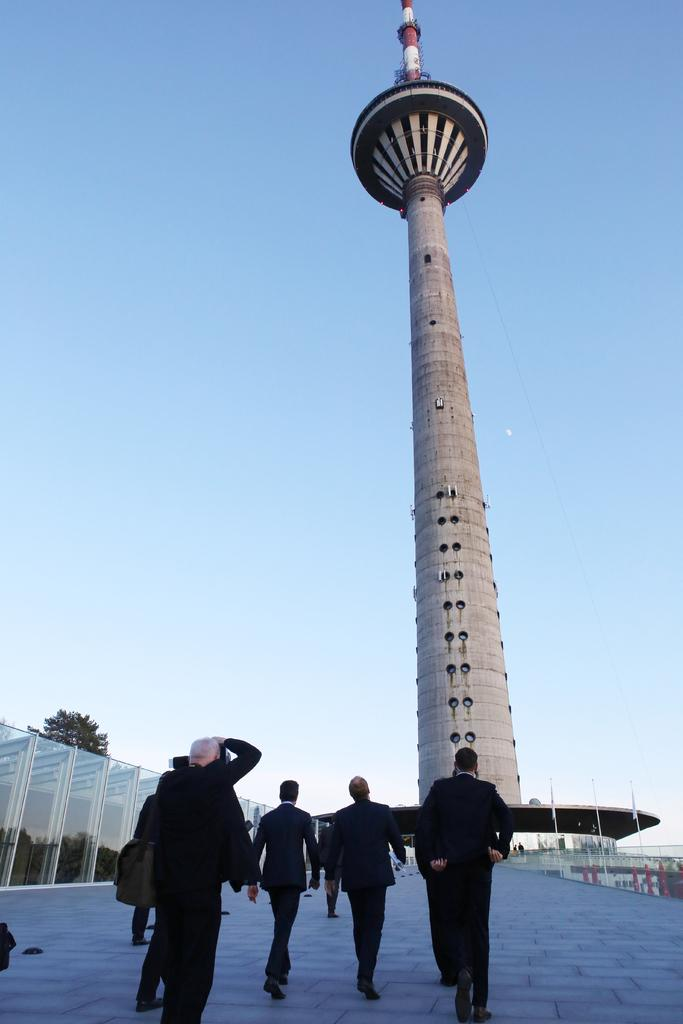How many people are in the image? There is a group of people in the image, but the exact number is not specified. What are the people in the image doing? Some people are standing, while others are walking. What objects can be seen in the image? Glasses are visible in the image. What type of vegetation is present in the image? There are trees in the image. What structure can be seen in the image? There is a tower in the image. Can you tell me how many snakes are slithering around the tower in the image? There are no snakes present in the image; it features a group of people, glasses, trees, and a tower. What type of question is being asked by the maid in the image? There is no maid or question being asked in the image. 